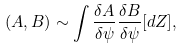Convert formula to latex. <formula><loc_0><loc_0><loc_500><loc_500>( A , B ) \sim \int \frac { \delta A } { \delta \psi } \frac { \delta B } { \delta \psi } [ d Z ] ,</formula> 